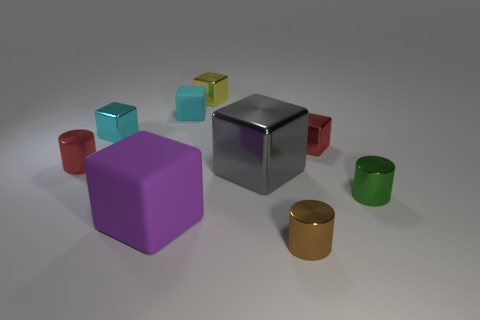Subtract all small brown cylinders. How many cylinders are left? 2 Subtract 2 cylinders. How many cylinders are left? 1 Subtract all red blocks. How many blocks are left? 5 Subtract all brown cubes. Subtract all blue balls. How many cubes are left? 6 Add 4 cubes. How many cubes exist? 10 Subtract 0 brown spheres. How many objects are left? 9 Subtract all cylinders. How many objects are left? 6 Subtract all gray balls. How many cyan cubes are left? 2 Subtract all large gray metallic objects. Subtract all tiny cyan rubber things. How many objects are left? 7 Add 3 green things. How many green things are left? 4 